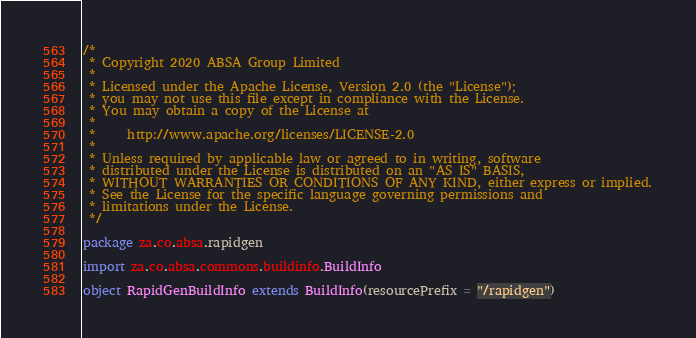<code> <loc_0><loc_0><loc_500><loc_500><_Scala_>/*
 * Copyright 2020 ABSA Group Limited
 *
 * Licensed under the Apache License, Version 2.0 (the "License");
 * you may not use this file except in compliance with the License.
 * You may obtain a copy of the License at
 *
 *     http://www.apache.org/licenses/LICENSE-2.0
 *
 * Unless required by applicable law or agreed to in writing, software
 * distributed under the License is distributed on an "AS IS" BASIS,
 * WITHOUT WARRANTIES OR CONDITIONS OF ANY KIND, either express or implied.
 * See the License for the specific language governing permissions and
 * limitations under the License.
 */

package za.co.absa.rapidgen

import za.co.absa.commons.buildinfo.BuildInfo

object RapidGenBuildInfo extends BuildInfo(resourcePrefix = "/rapidgen")
</code> 